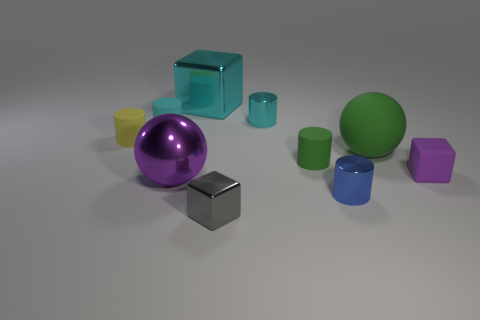Subtract all yellow cylinders. Subtract all cyan cubes. How many cylinders are left? 4 Subtract all red cubes. How many yellow spheres are left? 0 Add 4 small purples. How many small cyans exist? 0 Subtract all big cyan metallic objects. Subtract all tiny yellow matte things. How many objects are left? 8 Add 4 small rubber cylinders. How many small rubber cylinders are left? 7 Add 6 tiny cyan spheres. How many tiny cyan spheres exist? 6 Subtract all cyan cubes. How many cubes are left? 2 Subtract all tiny gray shiny cubes. How many cubes are left? 2 Subtract 0 red balls. How many objects are left? 10 Subtract all cyan cylinders. How many were subtracted if there are1cyan cylinders left? 1 